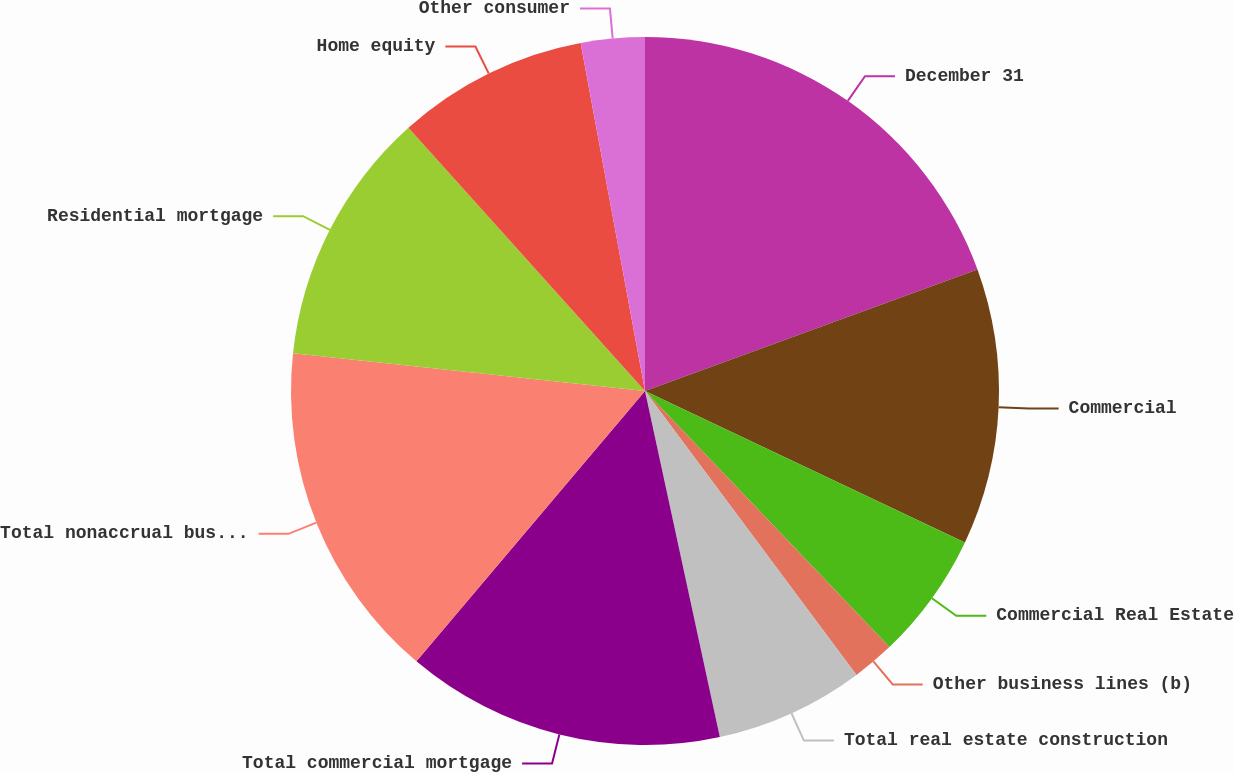<chart> <loc_0><loc_0><loc_500><loc_500><pie_chart><fcel>December 31<fcel>Commercial<fcel>Commercial Real Estate<fcel>Other business lines (b)<fcel>Total real estate construction<fcel>Total commercial mortgage<fcel>Total nonaccrual business<fcel>Residential mortgage<fcel>Home equity<fcel>Other consumer<nl><fcel>19.42%<fcel>12.62%<fcel>5.83%<fcel>1.94%<fcel>6.8%<fcel>14.56%<fcel>15.53%<fcel>11.65%<fcel>8.74%<fcel>2.91%<nl></chart> 